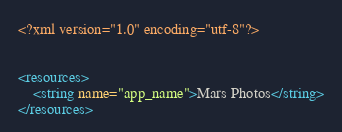<code> <loc_0><loc_0><loc_500><loc_500><_XML_><?xml version="1.0" encoding="utf-8"?>


<resources>
    <string name="app_name">Mars Photos</string>
</resources></code> 